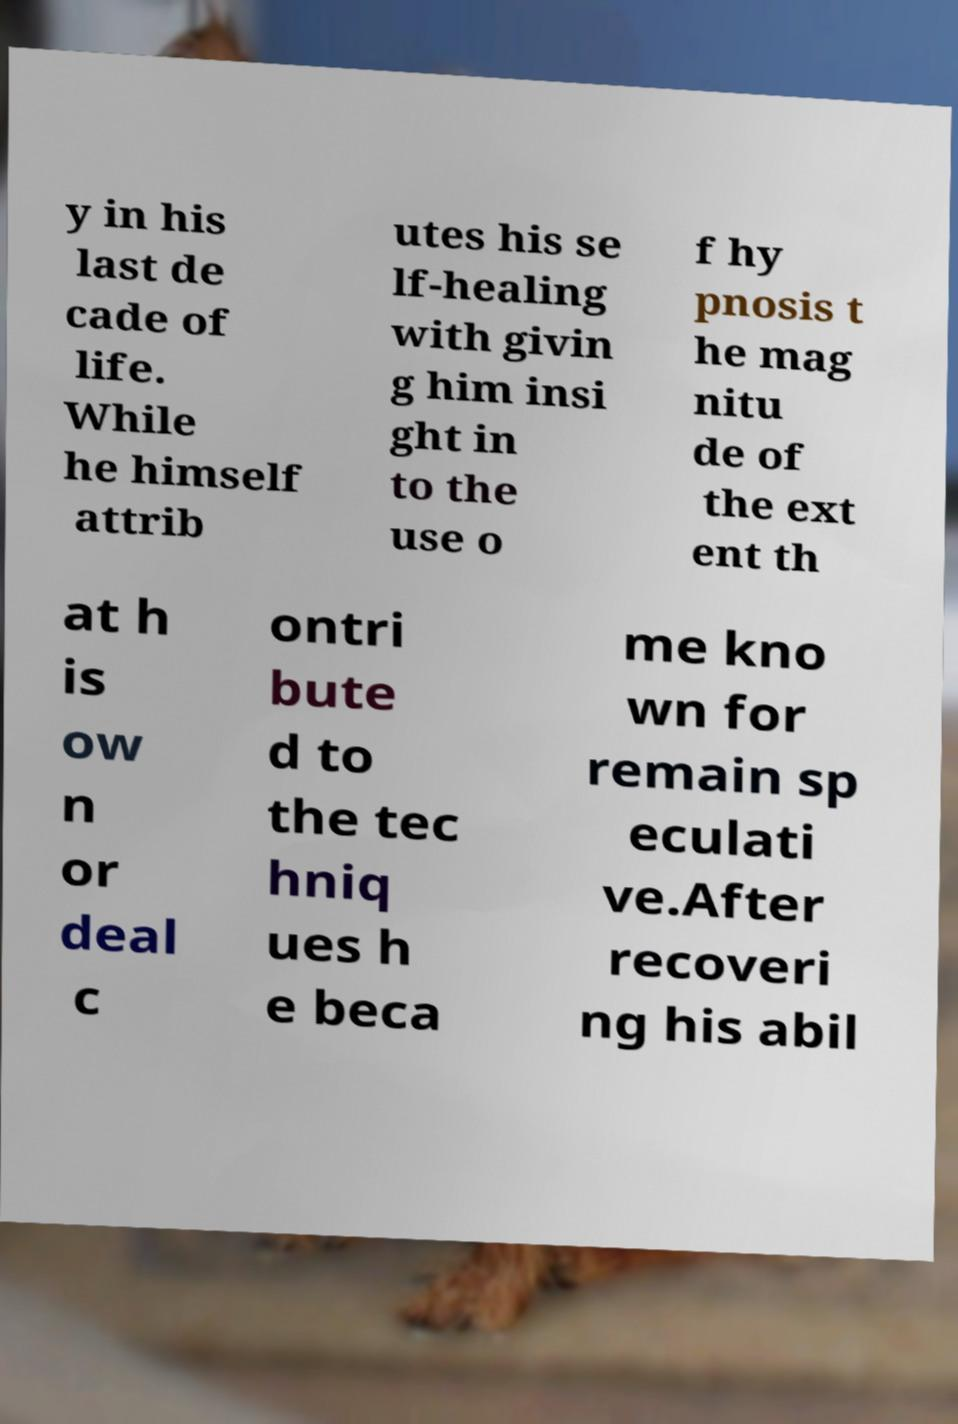For documentation purposes, I need the text within this image transcribed. Could you provide that? y in his last de cade of life. While he himself attrib utes his se lf-healing with givin g him insi ght in to the use o f hy pnosis t he mag nitu de of the ext ent th at h is ow n or deal c ontri bute d to the tec hniq ues h e beca me kno wn for remain sp eculati ve.After recoveri ng his abil 